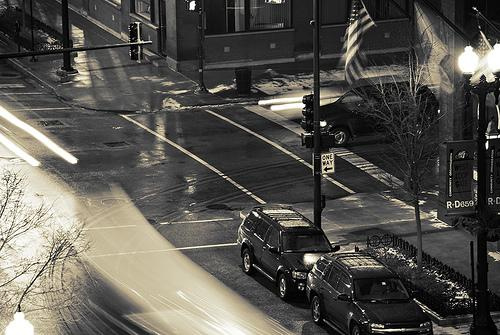What flag can be seen here? american 